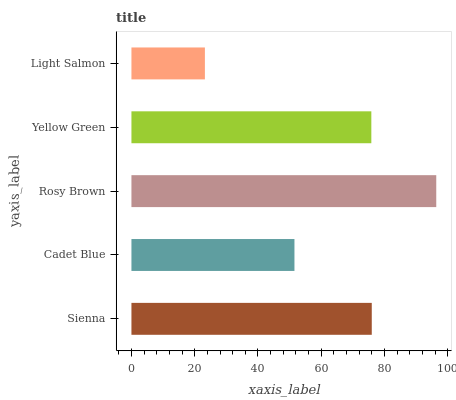Is Light Salmon the minimum?
Answer yes or no. Yes. Is Rosy Brown the maximum?
Answer yes or no. Yes. Is Cadet Blue the minimum?
Answer yes or no. No. Is Cadet Blue the maximum?
Answer yes or no. No. Is Sienna greater than Cadet Blue?
Answer yes or no. Yes. Is Cadet Blue less than Sienna?
Answer yes or no. Yes. Is Cadet Blue greater than Sienna?
Answer yes or no. No. Is Sienna less than Cadet Blue?
Answer yes or no. No. Is Yellow Green the high median?
Answer yes or no. Yes. Is Yellow Green the low median?
Answer yes or no. Yes. Is Cadet Blue the high median?
Answer yes or no. No. Is Rosy Brown the low median?
Answer yes or no. No. 